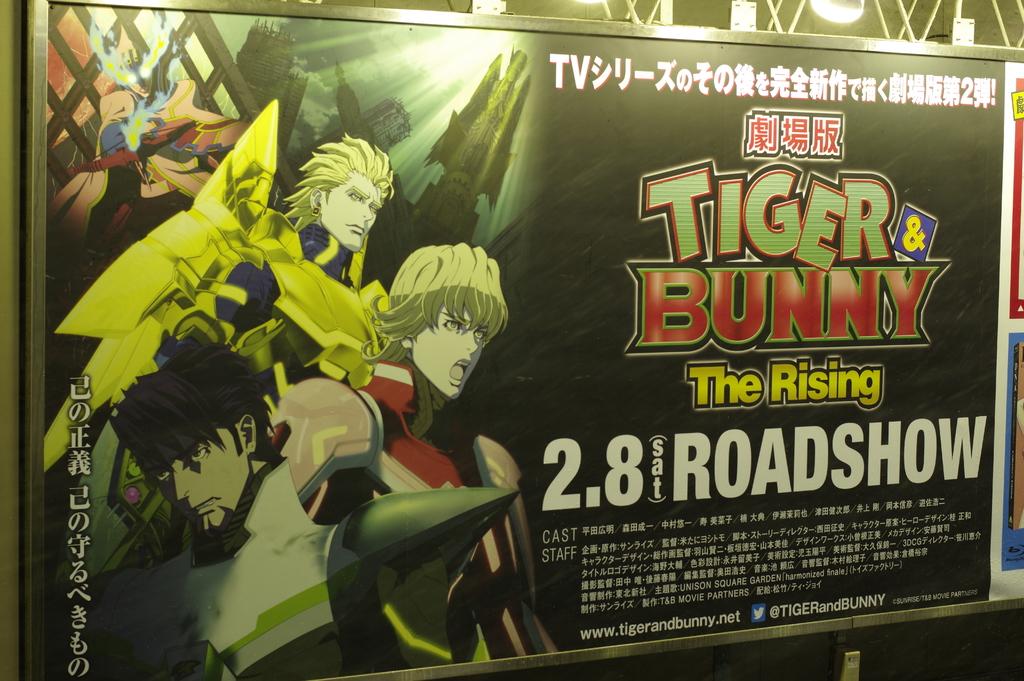What is this ad for?
Your answer should be very brief. Tiger & bunny. What is the day of the roadshow?
Offer a terse response. Saturday. 